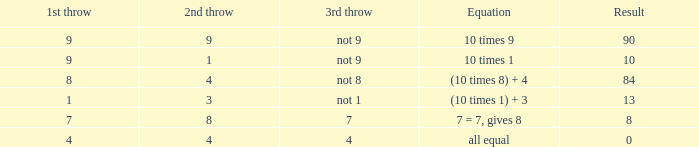If the equation is (10 times 1) + 3, what is the 2nd throw? 3.0. 